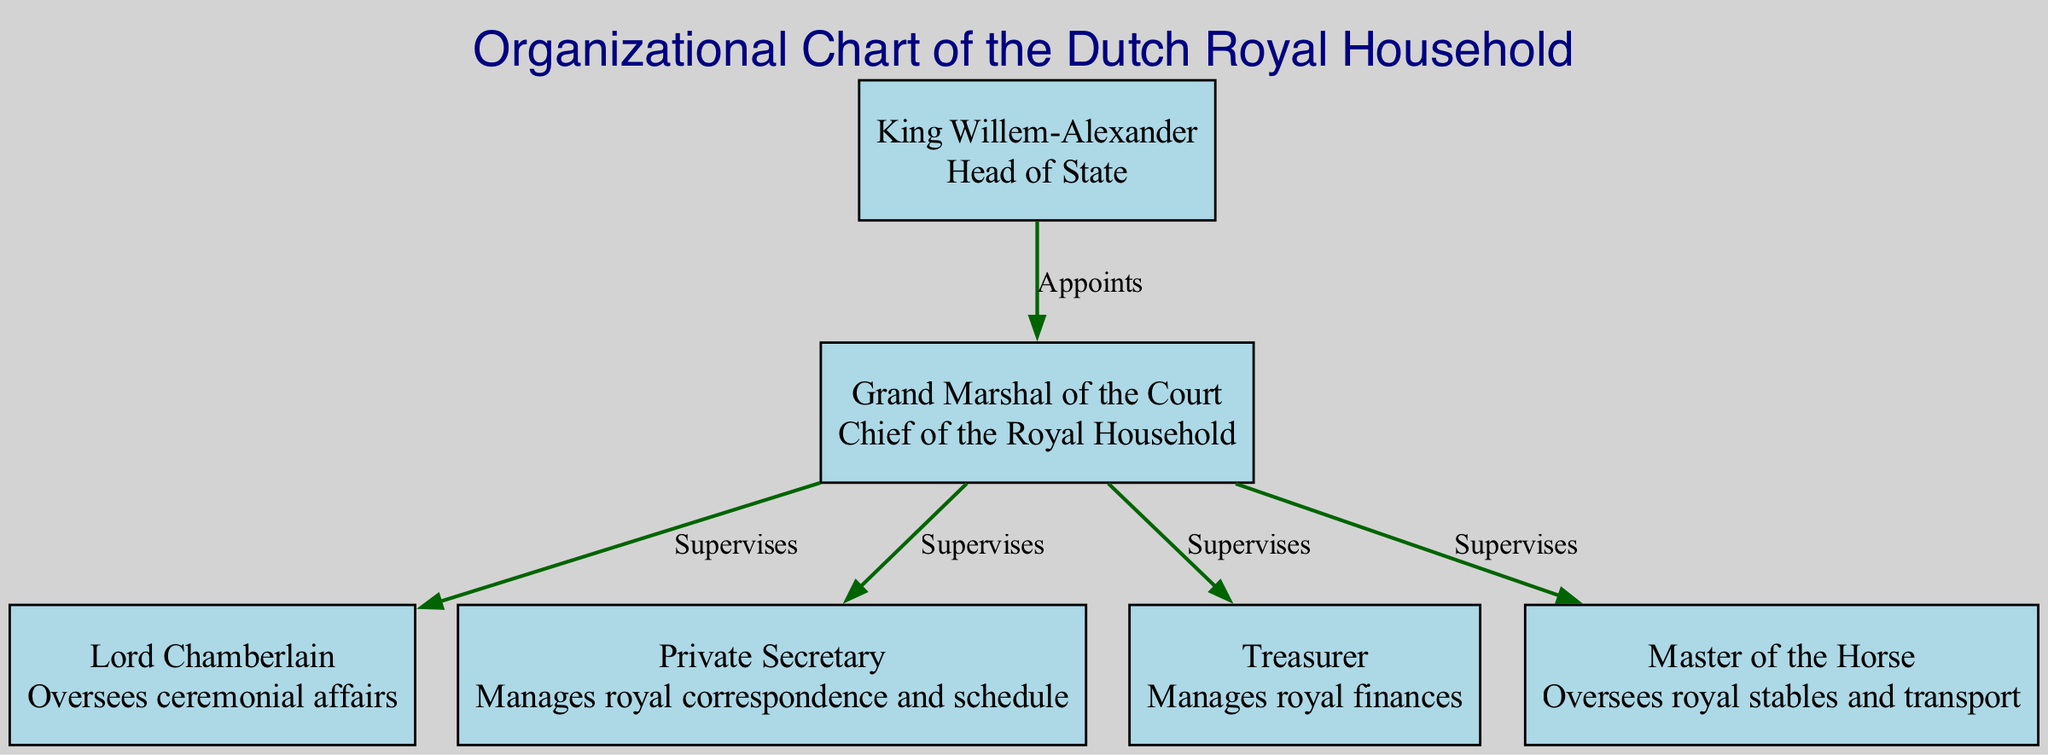What is the title of the diagram? The title of the diagram is provided in the data structure as "Organizational Chart of the Dutch Royal Household."
Answer: Organizational Chart of the Dutch Royal Household How many nodes are in the diagram? The data shows that there are 6 nodes representing different roles within the Dutch royal household.
Answer: 6 Who appoints the Grand Marshal of the Court? By examining the edges, it is clear that the King Willem-Alexander is the one who appoints the Grand Marshal of the Court.
Answer: King Willem-Alexander What position supervises the Lord Chamberlain? The Grand Marshal of the Court is indicated to supervise the Lord Chamberlain according to the relationship in the edges.
Answer: Grand Marshal of the Court Which role manages royal finances? The Treasurer is specified as the role that manages royal finances in the nodes section of the diagram.
Answer: Treasurer What is the relationship between the Grand Marshal and the Treasurer? The edge indicates that the Grand Marshal supervises the Treasurer, establishing a direct managerial relationship between the two.
Answer: Supervises Who describes the responsibilities of the royal correspondence? The Private Secretary is responsible for managing royal correspondence as per the description provided in the nodes.
Answer: Private Secretary What type of diagram is this? This is an organizational chart, as indicated by the title and the structuring of nodes and edges representing relationships between roles.
Answer: Organizational chart How many supervisions are indicated in the diagram? The edges reveal that there are 4 instances where the Grand Marshal supervises other positions in the chart.
Answer: 4 